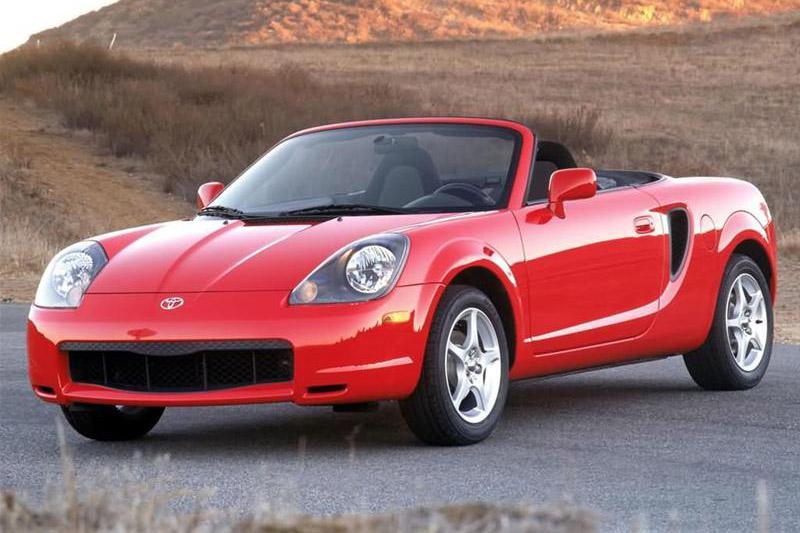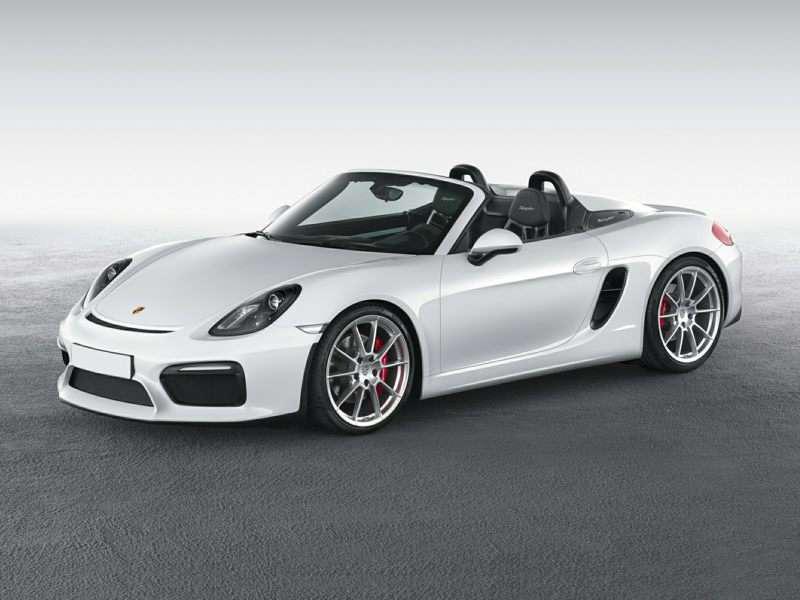The first image is the image on the left, the second image is the image on the right. Considering the images on both sides, is "An image shows one red convertible with top down, turned at a leftward-facing angle." valid? Answer yes or no. Yes. 